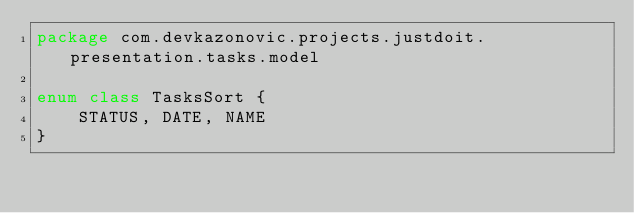<code> <loc_0><loc_0><loc_500><loc_500><_Kotlin_>package com.devkazonovic.projects.justdoit.presentation.tasks.model

enum class TasksSort {
    STATUS, DATE, NAME
}</code> 